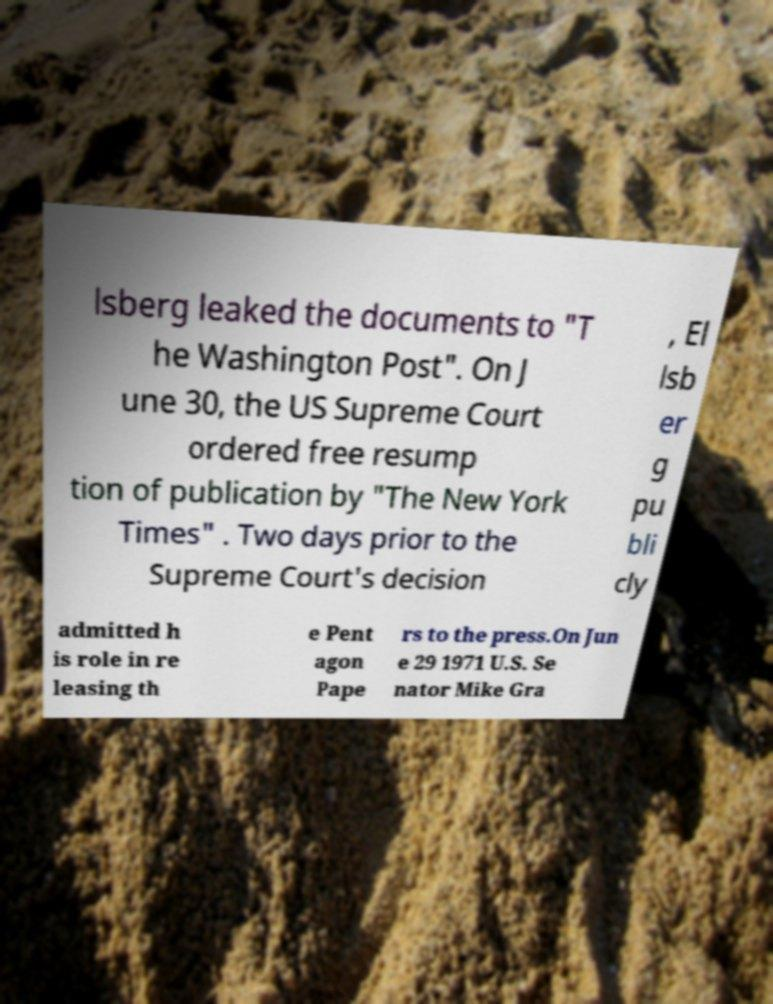Please read and relay the text visible in this image. What does it say? lsberg leaked the documents to "T he Washington Post". On J une 30, the US Supreme Court ordered free resump tion of publication by "The New York Times" . Two days prior to the Supreme Court's decision , El lsb er g pu bli cly admitted h is role in re leasing th e Pent agon Pape rs to the press.On Jun e 29 1971 U.S. Se nator Mike Gra 